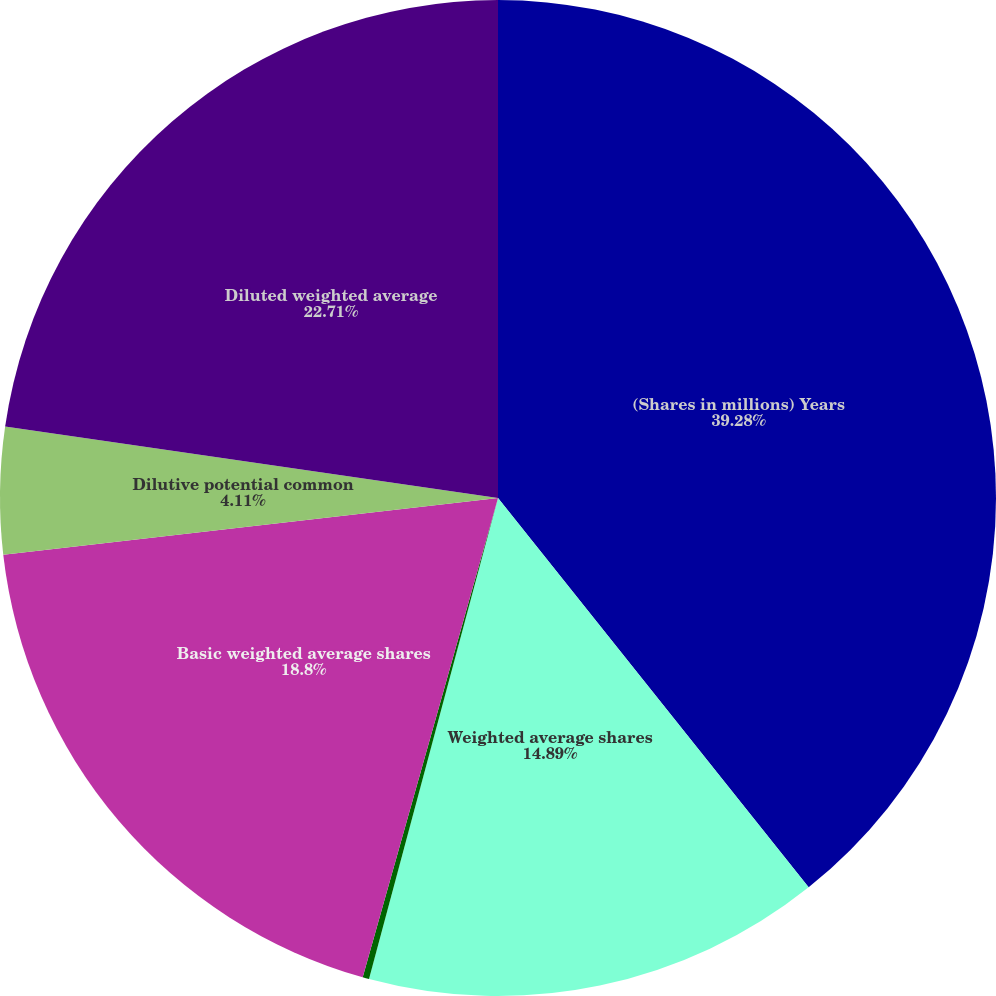Convert chart. <chart><loc_0><loc_0><loc_500><loc_500><pie_chart><fcel>(Shares in millions) Years<fcel>Weighted average shares<fcel>Participating securities<fcel>Basic weighted average shares<fcel>Dilutive potential common<fcel>Diluted weighted average<nl><fcel>39.28%<fcel>14.89%<fcel>0.21%<fcel>18.8%<fcel>4.11%<fcel>22.71%<nl></chart> 